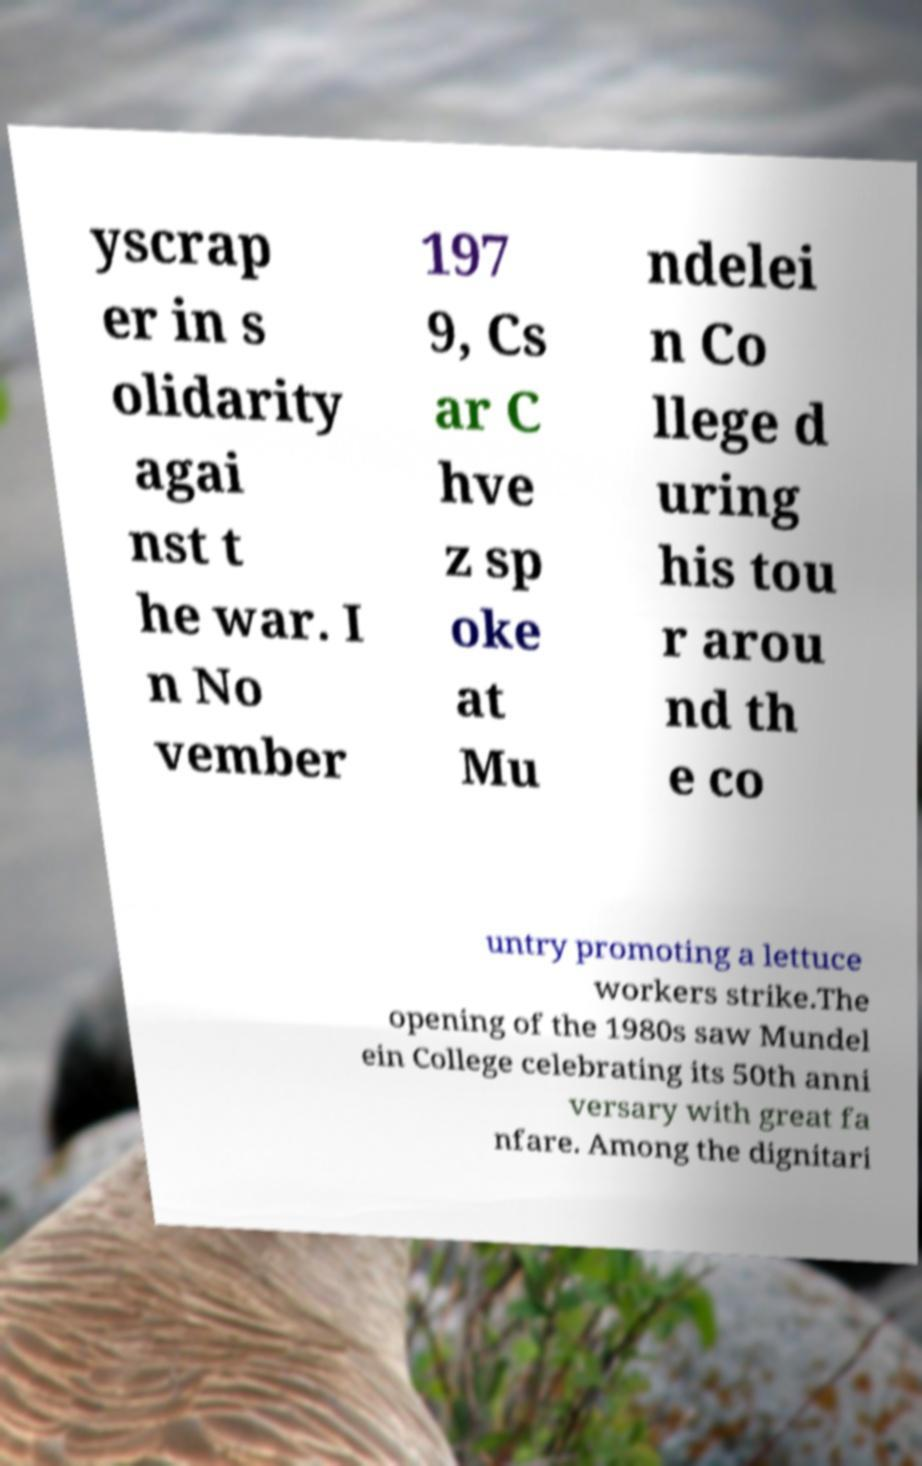Please identify and transcribe the text found in this image. yscrap er in s olidarity agai nst t he war. I n No vember 197 9, Cs ar C hve z sp oke at Mu ndelei n Co llege d uring his tou r arou nd th e co untry promoting a lettuce workers strike.The opening of the 1980s saw Mundel ein College celebrating its 50th anni versary with great fa nfare. Among the dignitari 